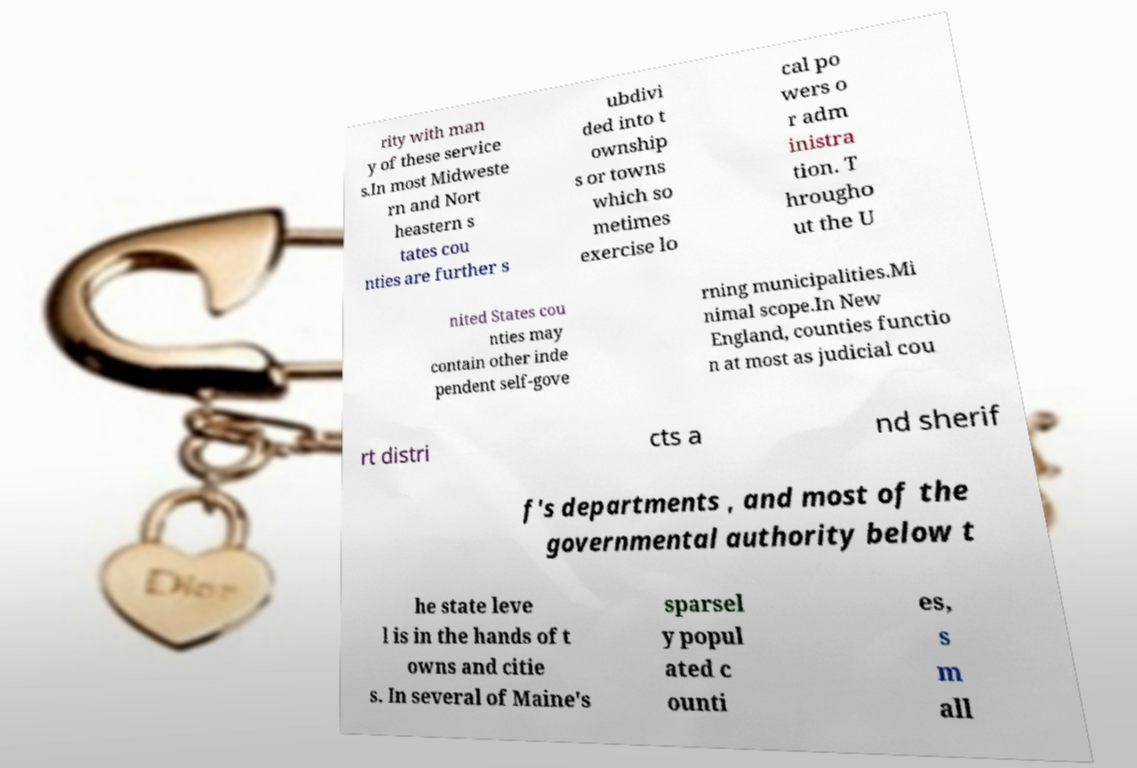I need the written content from this picture converted into text. Can you do that? rity with man y of these service s.In most Midweste rn and Nort heastern s tates cou nties are further s ubdivi ded into t ownship s or towns which so metimes exercise lo cal po wers o r adm inistra tion. T hrougho ut the U nited States cou nties may contain other inde pendent self-gove rning municipalities.Mi nimal scope.In New England, counties functio n at most as judicial cou rt distri cts a nd sherif f's departments , and most of the governmental authority below t he state leve l is in the hands of t owns and citie s. In several of Maine's sparsel y popul ated c ounti es, s m all 